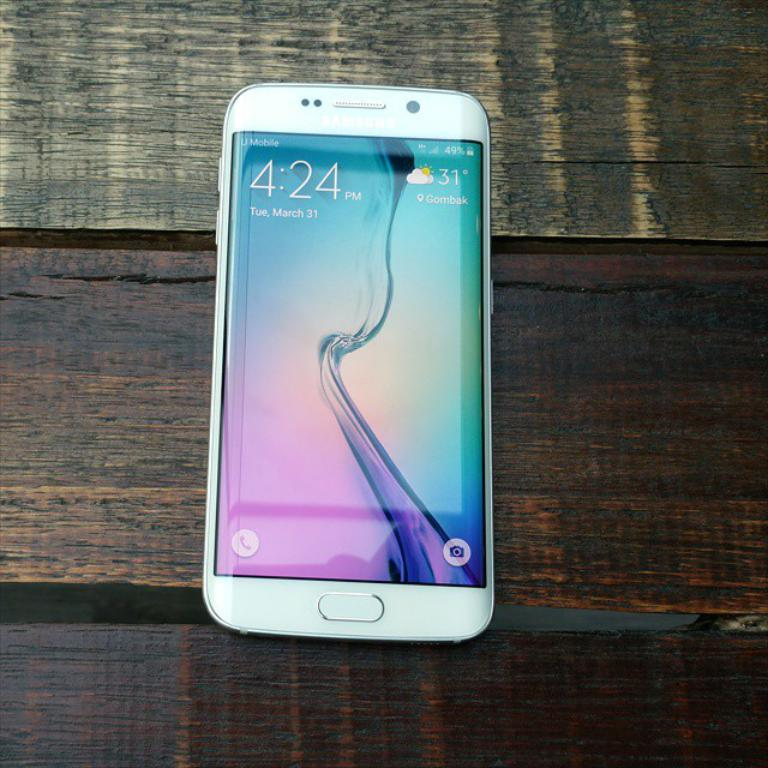<image>
Summarize the visual content of the image. A white cell phone on a wood table displaying that it's 31 degrees in Gombak. 